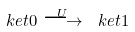Convert formula to latex. <formula><loc_0><loc_0><loc_500><loc_500>\ k e t { 0 } \stackrel { U } { \longrightarrow } \ k e t { 1 }</formula> 